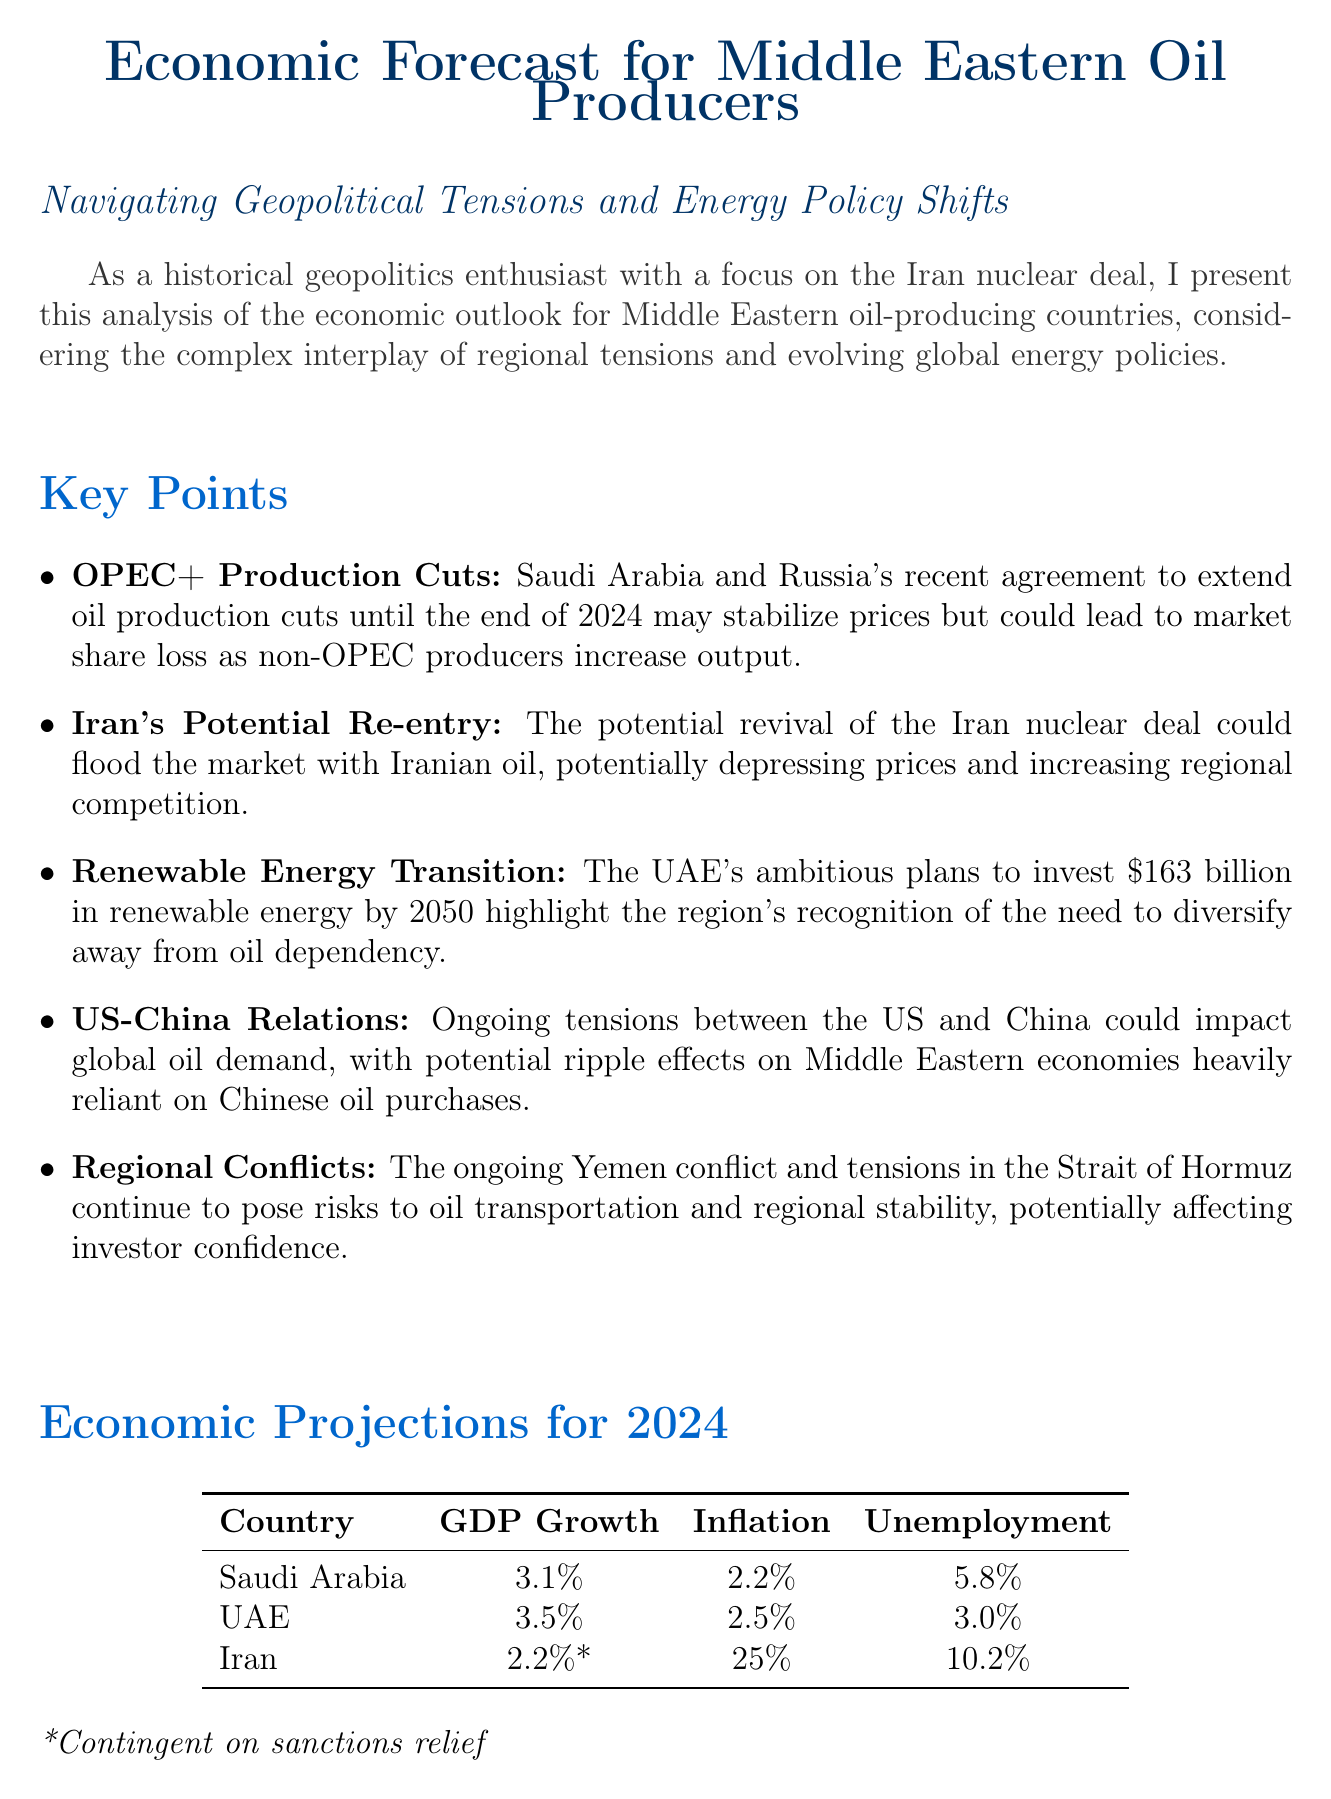what is the title of the report? The title of the report is listed at the beginning of the document.
Answer: Economic Forecast for Middle Eastern Oil Producers: Navigating Geopolitical Tensions and Energy Policy Shifts which country has the highest projected GDP growth for 2024? The projected GDP growth for each country is presented in a table; the highest is for the UAE.
Answer: UAE what is Iran's inflation rate projected for 2024? The inflation rate for Iran is specified in the economic projections section of the document.
Answer: 25% what geopolitical factor could impact global oil demand? The document mentions specific geopolitical relationships that could affect demand, particularly the US-China tensions.
Answer: US-China Relations how much is the UAE investing in renewable energy by 2050? The investment amount for UAE’s renewable energy plans is detailed in the key points section.
Answer: $163 billion what is the unemployment rate projected for Saudi Arabia in 2024? The unemployment rate for Saudi Arabia is found in the economic projections section of the document.
Answer: 5.8% what ongoing conflict poses risks to oil transportation? The document discusses various regional conflicts that pose risks; one mentioned is the Yemen conflict.
Answer: Yemen conflict which two countries agreed to extend oil production cuts until the end of 2024? The key points section mentions a specific agreement related to oil production cuts between two countries.
Answer: Saudi Arabia and Russia 